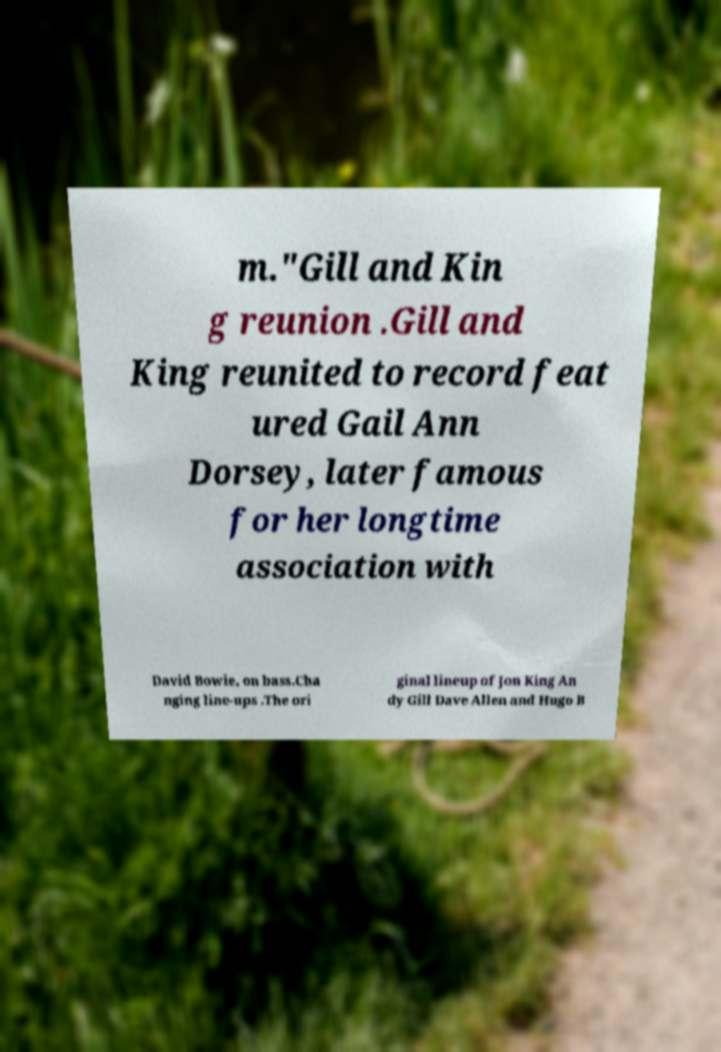Can you read and provide the text displayed in the image?This photo seems to have some interesting text. Can you extract and type it out for me? m."Gill and Kin g reunion .Gill and King reunited to record feat ured Gail Ann Dorsey, later famous for her longtime association with David Bowie, on bass.Cha nging line-ups .The ori ginal lineup of Jon King An dy Gill Dave Allen and Hugo B 